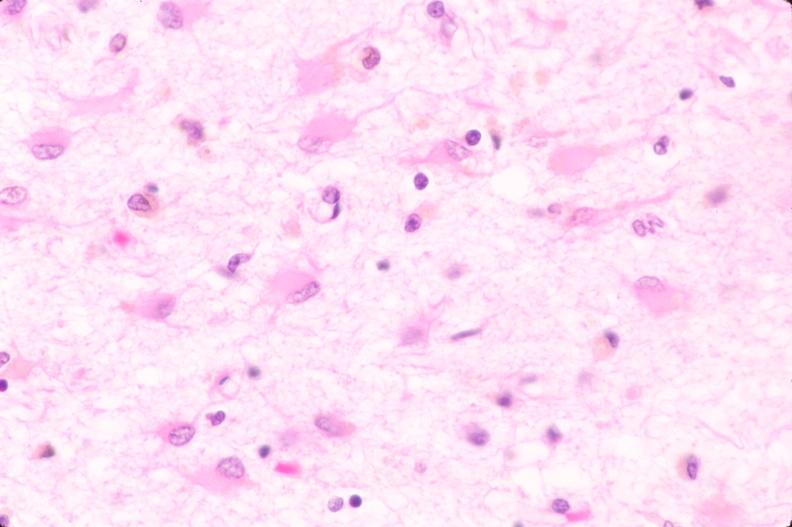why does this image show brain, infarct?
Answer the question using a single word or phrase. Due to ruptured saccular aneurysm and thrombosis of right middle cerebral artery plasmacytic astrocytes 